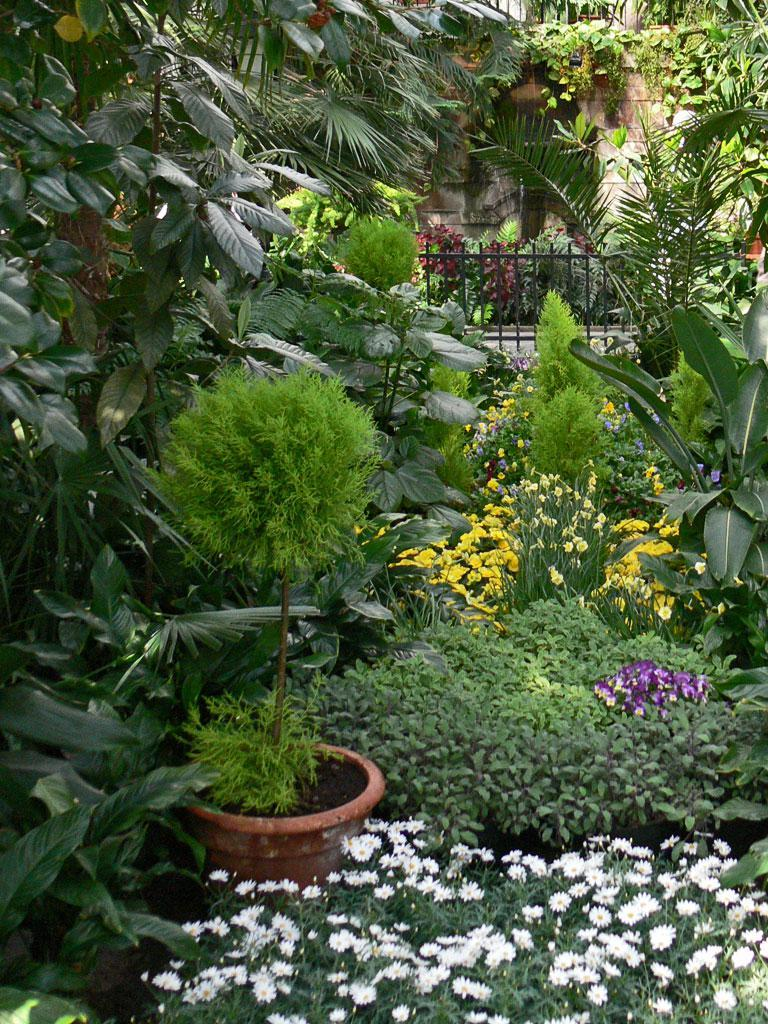What types of living organisms can be seen in the image? There are multiple plants in the image. Are there any specific features of the plants? Yes, there are flowers in the image. What colors are the flowers? The flowers are white, violet, and yellow in color. What can be seen in the background of the image? There is fencing and a wall visible in the image. What type of instrument is being played by the grape in the image? There is no grape present in the image, and therefore no instrument being played by it. 